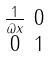Convert formula to latex. <formula><loc_0><loc_0><loc_500><loc_500>\begin{smallmatrix} \frac { 1 } { \varpi x } & 0 \\ 0 & 1 \end{smallmatrix}</formula> 